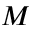Convert formula to latex. <formula><loc_0><loc_0><loc_500><loc_500>M</formula> 